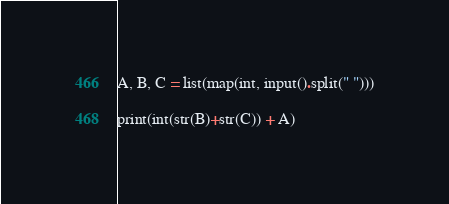Convert code to text. <code><loc_0><loc_0><loc_500><loc_500><_Python_>A, B, C = list(map(int, input().split(" ")))

print(int(str(B)+str(C)) + A)</code> 